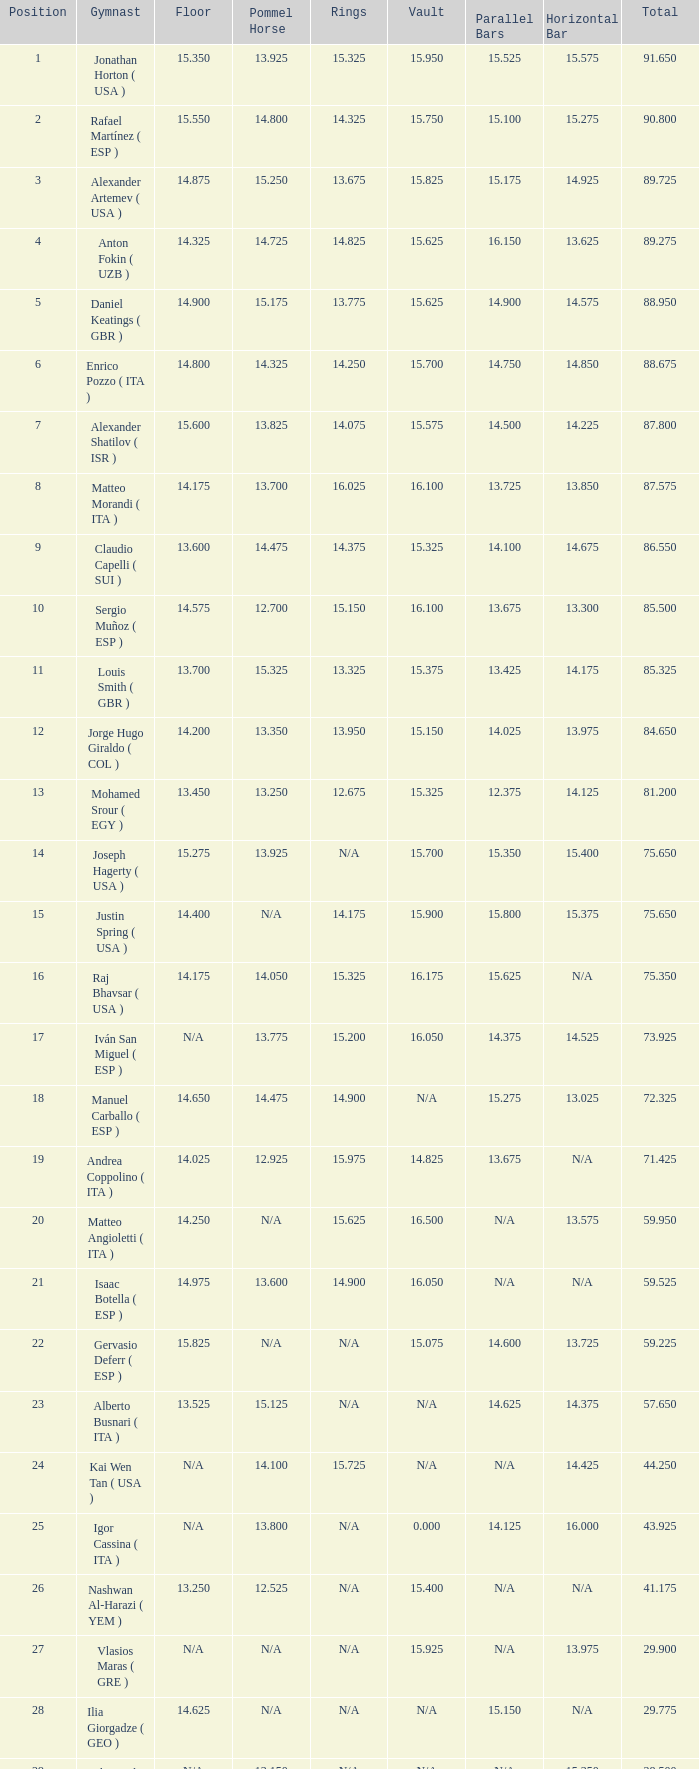With the floor number being 14.200, what number corresponds to the parallel bars? 14.025. 